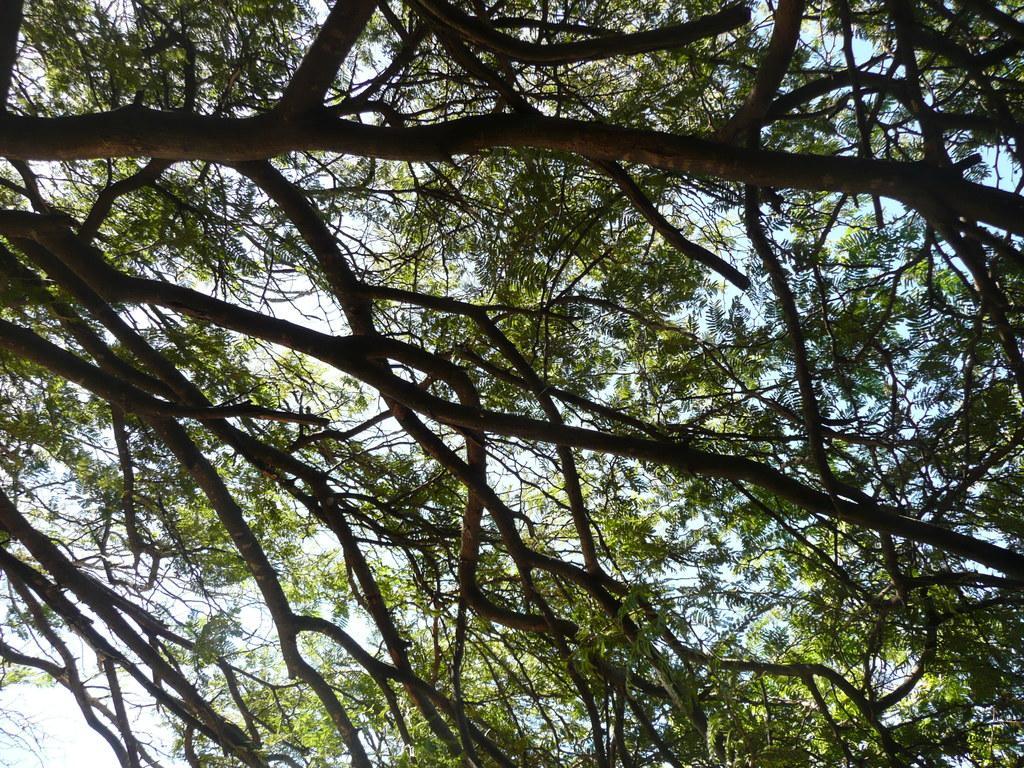In one or two sentences, can you explain what this image depicts? In this picture we can see trees and in the background we can see the sky. 